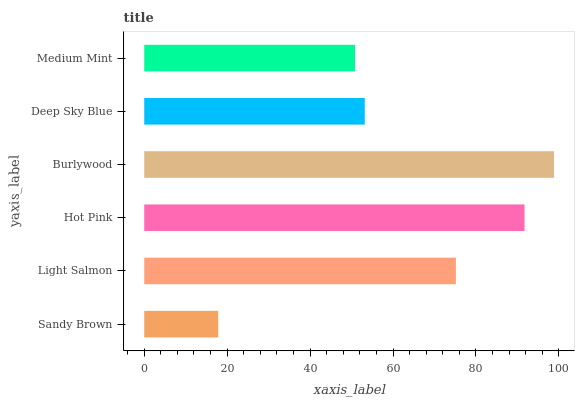Is Sandy Brown the minimum?
Answer yes or no. Yes. Is Burlywood the maximum?
Answer yes or no. Yes. Is Light Salmon the minimum?
Answer yes or no. No. Is Light Salmon the maximum?
Answer yes or no. No. Is Light Salmon greater than Sandy Brown?
Answer yes or no. Yes. Is Sandy Brown less than Light Salmon?
Answer yes or no. Yes. Is Sandy Brown greater than Light Salmon?
Answer yes or no. No. Is Light Salmon less than Sandy Brown?
Answer yes or no. No. Is Light Salmon the high median?
Answer yes or no. Yes. Is Deep Sky Blue the low median?
Answer yes or no. Yes. Is Medium Mint the high median?
Answer yes or no. No. Is Burlywood the low median?
Answer yes or no. No. 